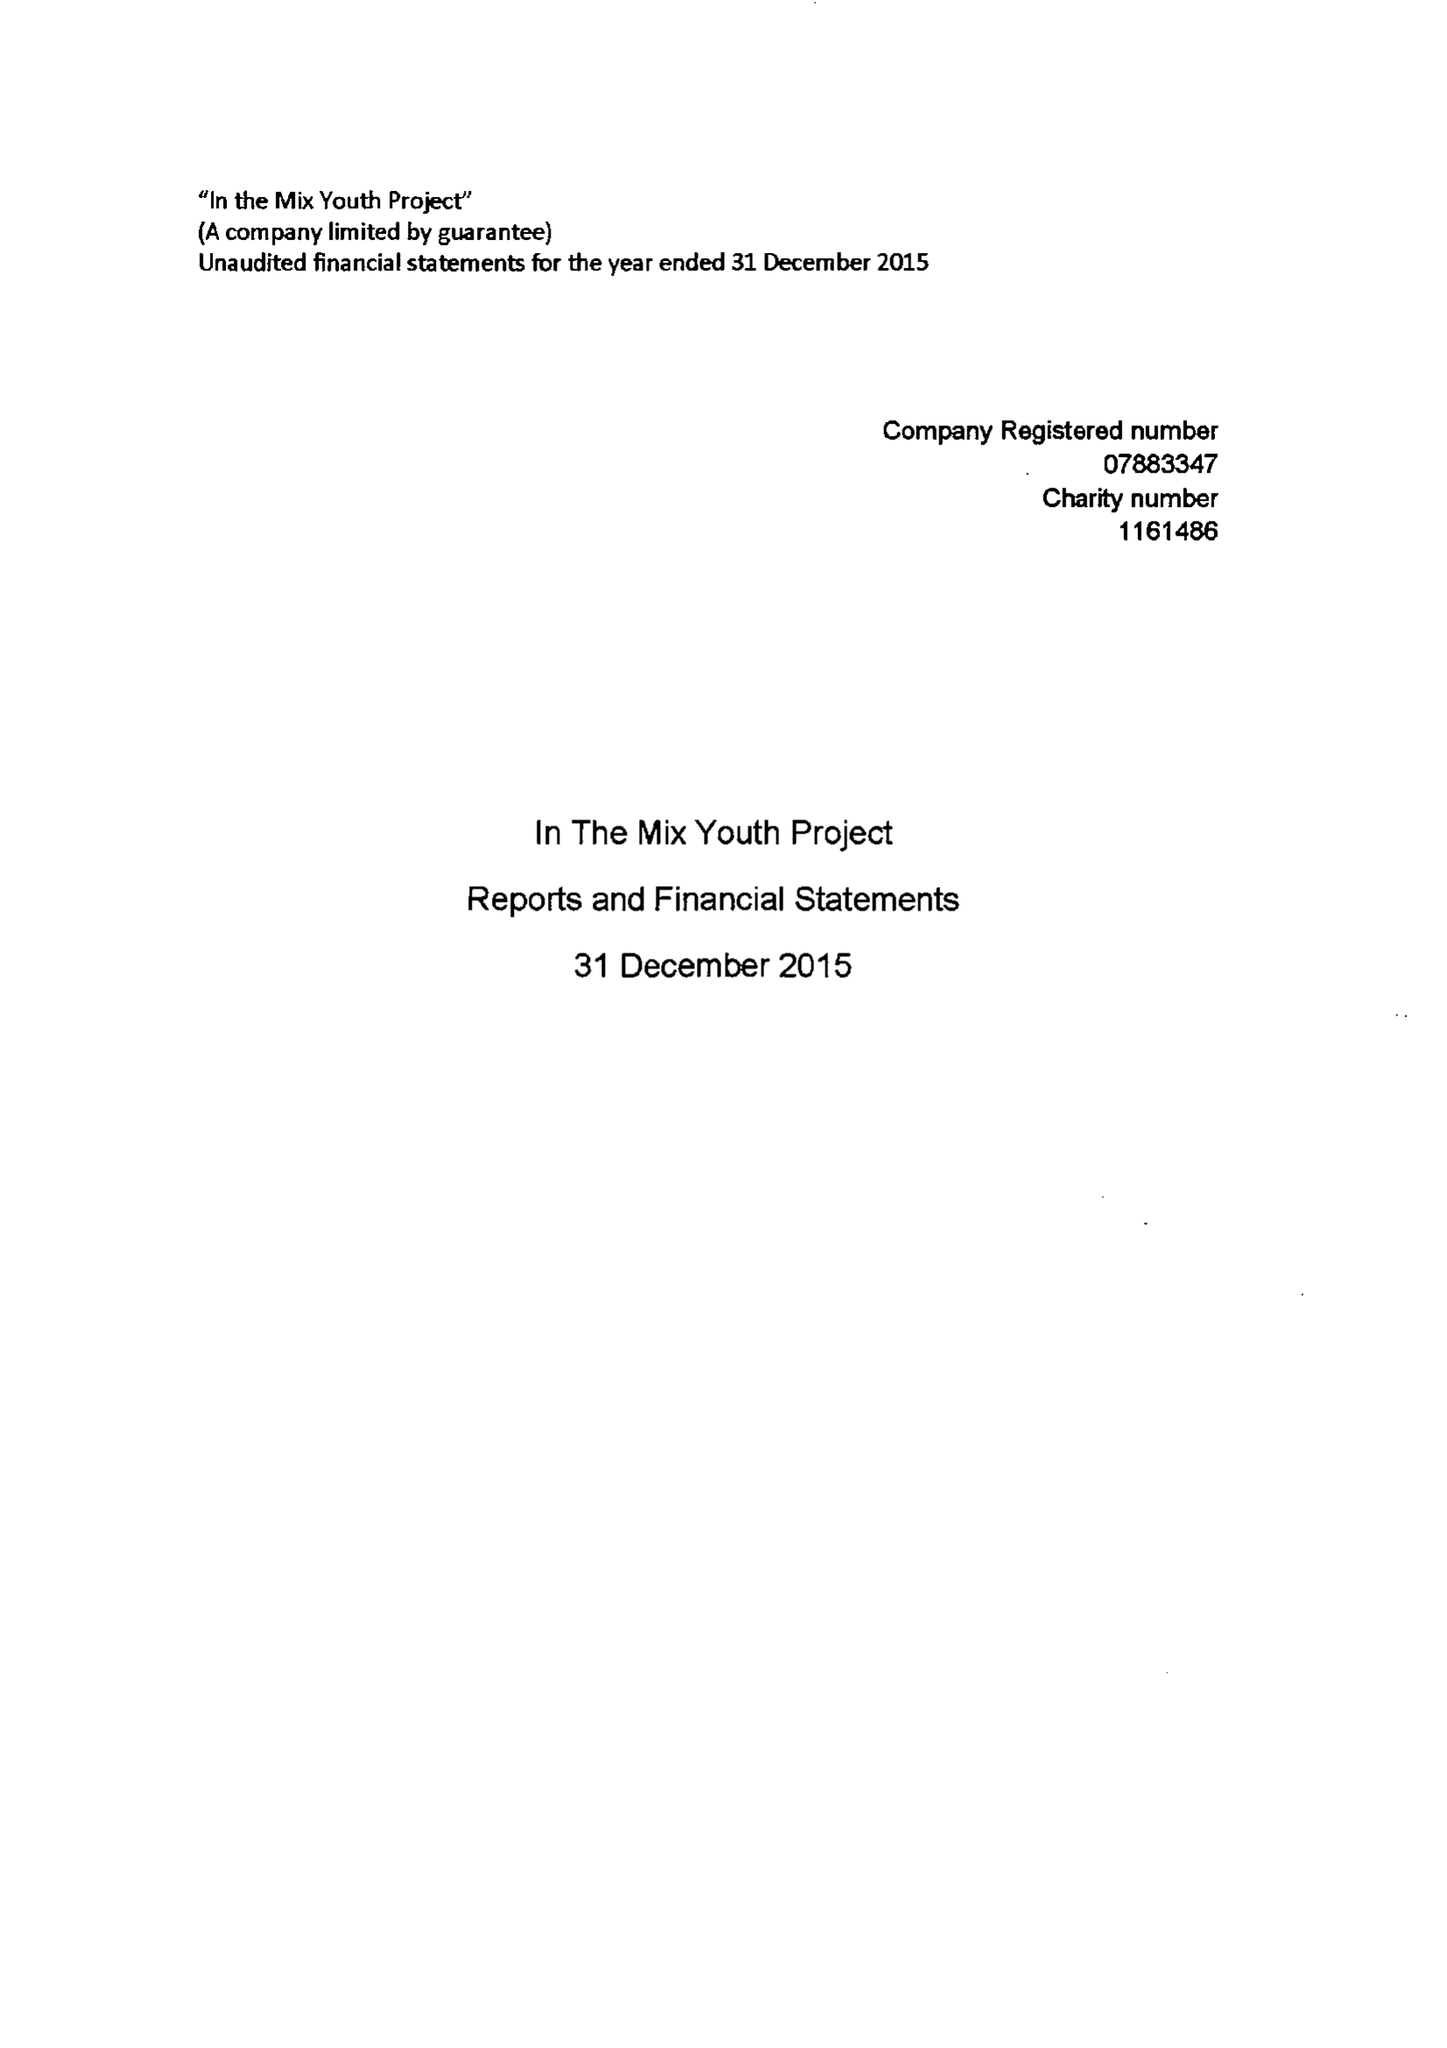What is the value for the charity_name?
Answer the question using a single word or phrase. In The Mix Youth Project 